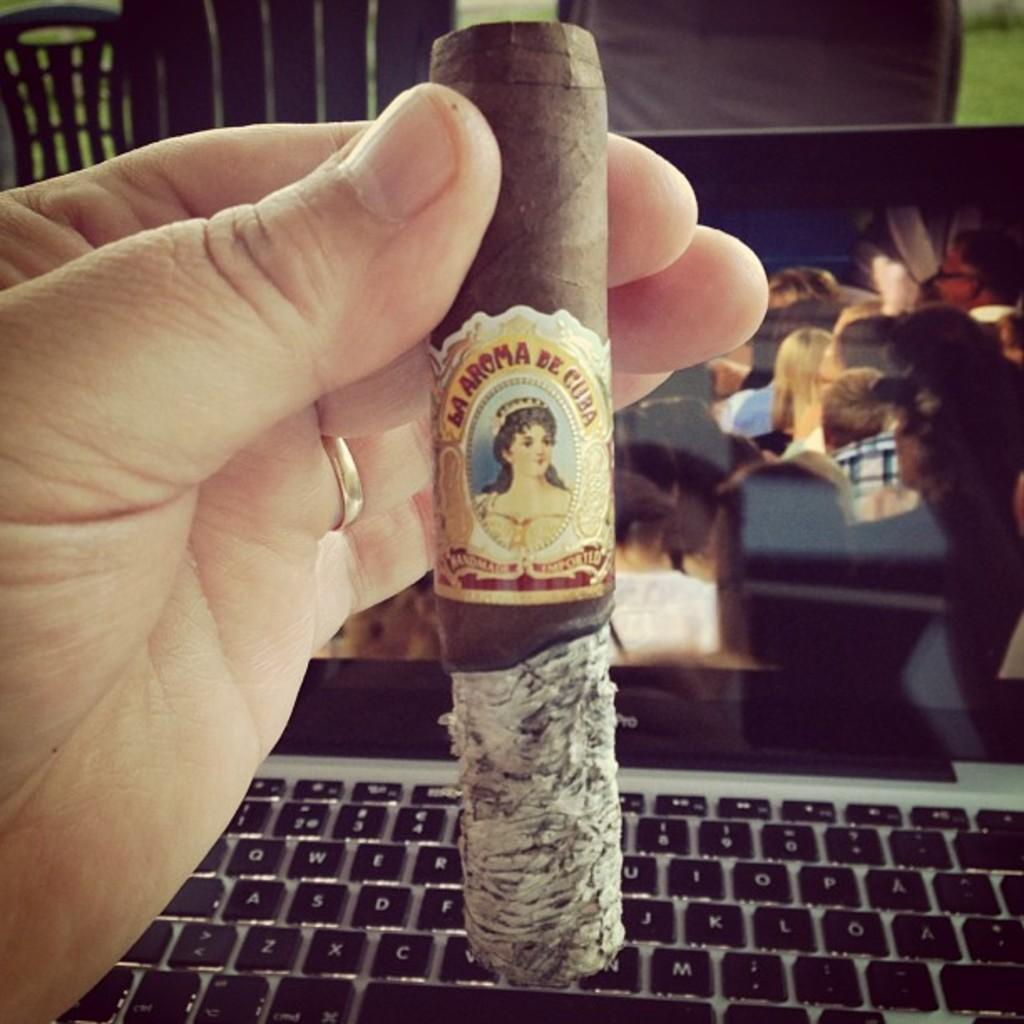<image>
Relay a brief, clear account of the picture shown. A person holding up a cigar that says la aroma de cuba 